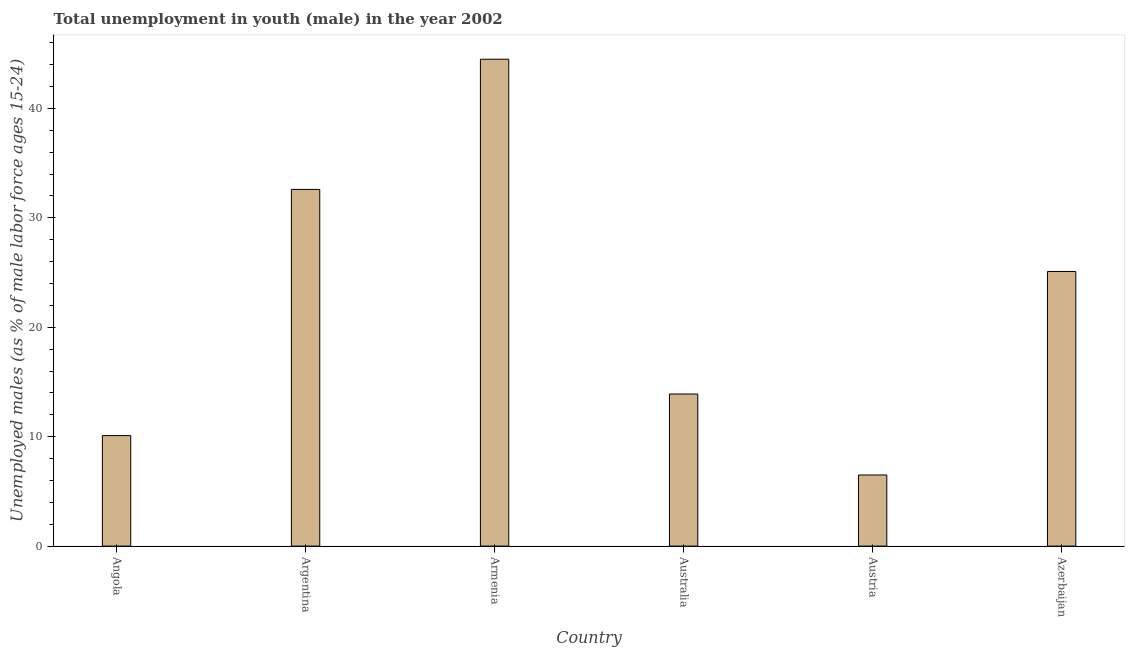Does the graph contain grids?
Ensure brevity in your answer.  No. What is the title of the graph?
Offer a terse response. Total unemployment in youth (male) in the year 2002. What is the label or title of the X-axis?
Ensure brevity in your answer.  Country. What is the label or title of the Y-axis?
Provide a short and direct response. Unemployed males (as % of male labor force ages 15-24). What is the unemployed male youth population in Armenia?
Provide a succinct answer. 44.5. Across all countries, what is the maximum unemployed male youth population?
Keep it short and to the point. 44.5. In which country was the unemployed male youth population maximum?
Keep it short and to the point. Armenia. In which country was the unemployed male youth population minimum?
Your answer should be very brief. Austria. What is the sum of the unemployed male youth population?
Offer a terse response. 132.7. What is the average unemployed male youth population per country?
Provide a short and direct response. 22.12. What is the median unemployed male youth population?
Your answer should be compact. 19.5. What is the ratio of the unemployed male youth population in Angola to that in Australia?
Your answer should be compact. 0.73. Is the difference between the unemployed male youth population in Argentina and Azerbaijan greater than the difference between any two countries?
Offer a very short reply. No. How many bars are there?
Your answer should be compact. 6. Are all the bars in the graph horizontal?
Make the answer very short. No. Are the values on the major ticks of Y-axis written in scientific E-notation?
Offer a terse response. No. What is the Unemployed males (as % of male labor force ages 15-24) in Angola?
Your response must be concise. 10.1. What is the Unemployed males (as % of male labor force ages 15-24) of Argentina?
Offer a very short reply. 32.6. What is the Unemployed males (as % of male labor force ages 15-24) in Armenia?
Make the answer very short. 44.5. What is the Unemployed males (as % of male labor force ages 15-24) of Australia?
Your answer should be very brief. 13.9. What is the Unemployed males (as % of male labor force ages 15-24) of Austria?
Provide a short and direct response. 6.5. What is the Unemployed males (as % of male labor force ages 15-24) in Azerbaijan?
Make the answer very short. 25.1. What is the difference between the Unemployed males (as % of male labor force ages 15-24) in Angola and Argentina?
Offer a terse response. -22.5. What is the difference between the Unemployed males (as % of male labor force ages 15-24) in Angola and Armenia?
Offer a very short reply. -34.4. What is the difference between the Unemployed males (as % of male labor force ages 15-24) in Angola and Australia?
Provide a succinct answer. -3.8. What is the difference between the Unemployed males (as % of male labor force ages 15-24) in Angola and Azerbaijan?
Make the answer very short. -15. What is the difference between the Unemployed males (as % of male labor force ages 15-24) in Argentina and Armenia?
Your answer should be very brief. -11.9. What is the difference between the Unemployed males (as % of male labor force ages 15-24) in Argentina and Australia?
Your response must be concise. 18.7. What is the difference between the Unemployed males (as % of male labor force ages 15-24) in Argentina and Austria?
Make the answer very short. 26.1. What is the difference between the Unemployed males (as % of male labor force ages 15-24) in Armenia and Australia?
Keep it short and to the point. 30.6. What is the difference between the Unemployed males (as % of male labor force ages 15-24) in Armenia and Austria?
Offer a very short reply. 38. What is the difference between the Unemployed males (as % of male labor force ages 15-24) in Austria and Azerbaijan?
Your answer should be compact. -18.6. What is the ratio of the Unemployed males (as % of male labor force ages 15-24) in Angola to that in Argentina?
Ensure brevity in your answer.  0.31. What is the ratio of the Unemployed males (as % of male labor force ages 15-24) in Angola to that in Armenia?
Your response must be concise. 0.23. What is the ratio of the Unemployed males (as % of male labor force ages 15-24) in Angola to that in Australia?
Offer a terse response. 0.73. What is the ratio of the Unemployed males (as % of male labor force ages 15-24) in Angola to that in Austria?
Offer a very short reply. 1.55. What is the ratio of the Unemployed males (as % of male labor force ages 15-24) in Angola to that in Azerbaijan?
Make the answer very short. 0.4. What is the ratio of the Unemployed males (as % of male labor force ages 15-24) in Argentina to that in Armenia?
Make the answer very short. 0.73. What is the ratio of the Unemployed males (as % of male labor force ages 15-24) in Argentina to that in Australia?
Provide a short and direct response. 2.35. What is the ratio of the Unemployed males (as % of male labor force ages 15-24) in Argentina to that in Austria?
Provide a short and direct response. 5.01. What is the ratio of the Unemployed males (as % of male labor force ages 15-24) in Argentina to that in Azerbaijan?
Make the answer very short. 1.3. What is the ratio of the Unemployed males (as % of male labor force ages 15-24) in Armenia to that in Australia?
Provide a succinct answer. 3.2. What is the ratio of the Unemployed males (as % of male labor force ages 15-24) in Armenia to that in Austria?
Your answer should be compact. 6.85. What is the ratio of the Unemployed males (as % of male labor force ages 15-24) in Armenia to that in Azerbaijan?
Give a very brief answer. 1.77. What is the ratio of the Unemployed males (as % of male labor force ages 15-24) in Australia to that in Austria?
Your response must be concise. 2.14. What is the ratio of the Unemployed males (as % of male labor force ages 15-24) in Australia to that in Azerbaijan?
Provide a short and direct response. 0.55. What is the ratio of the Unemployed males (as % of male labor force ages 15-24) in Austria to that in Azerbaijan?
Your answer should be very brief. 0.26. 